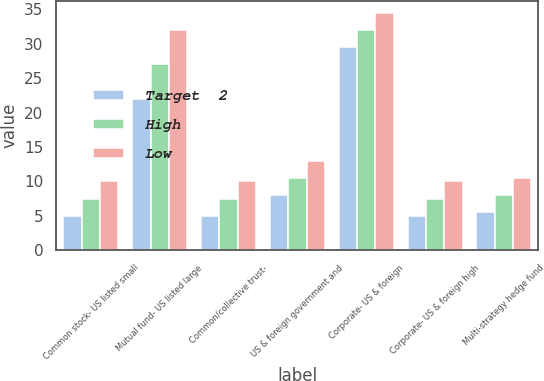Convert chart. <chart><loc_0><loc_0><loc_500><loc_500><stacked_bar_chart><ecel><fcel>Common stock- US listed small<fcel>Mutual fund- US listed large<fcel>Common/collective trust-<fcel>US & foreign government and<fcel>Corporate- US & foreign<fcel>Corporate- US & foreign high<fcel>Multi-strategy hedge fund<nl><fcel>Target  2<fcel>5<fcel>22<fcel>5<fcel>8<fcel>29.5<fcel>5<fcel>5.5<nl><fcel>High<fcel>7.5<fcel>27<fcel>7.5<fcel>10.5<fcel>32<fcel>7.5<fcel>8<nl><fcel>Low<fcel>10<fcel>32<fcel>10<fcel>13<fcel>34.5<fcel>10<fcel>10.5<nl></chart> 